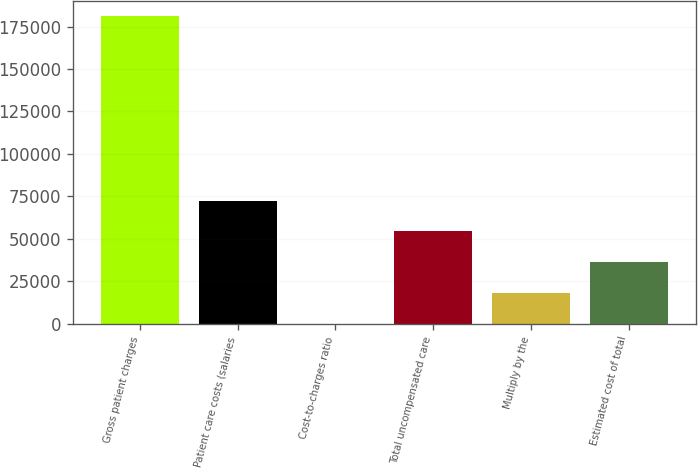<chart> <loc_0><loc_0><loc_500><loc_500><bar_chart><fcel>Gross patient charges<fcel>Patient care costs (salaries<fcel>Cost-to-charges ratio<fcel>Total uncompensated care<fcel>Multiply by the<fcel>Estimated cost of total<nl><fcel>181141<fcel>72466.2<fcel>16.3<fcel>54353.7<fcel>18128.8<fcel>36241.2<nl></chart> 